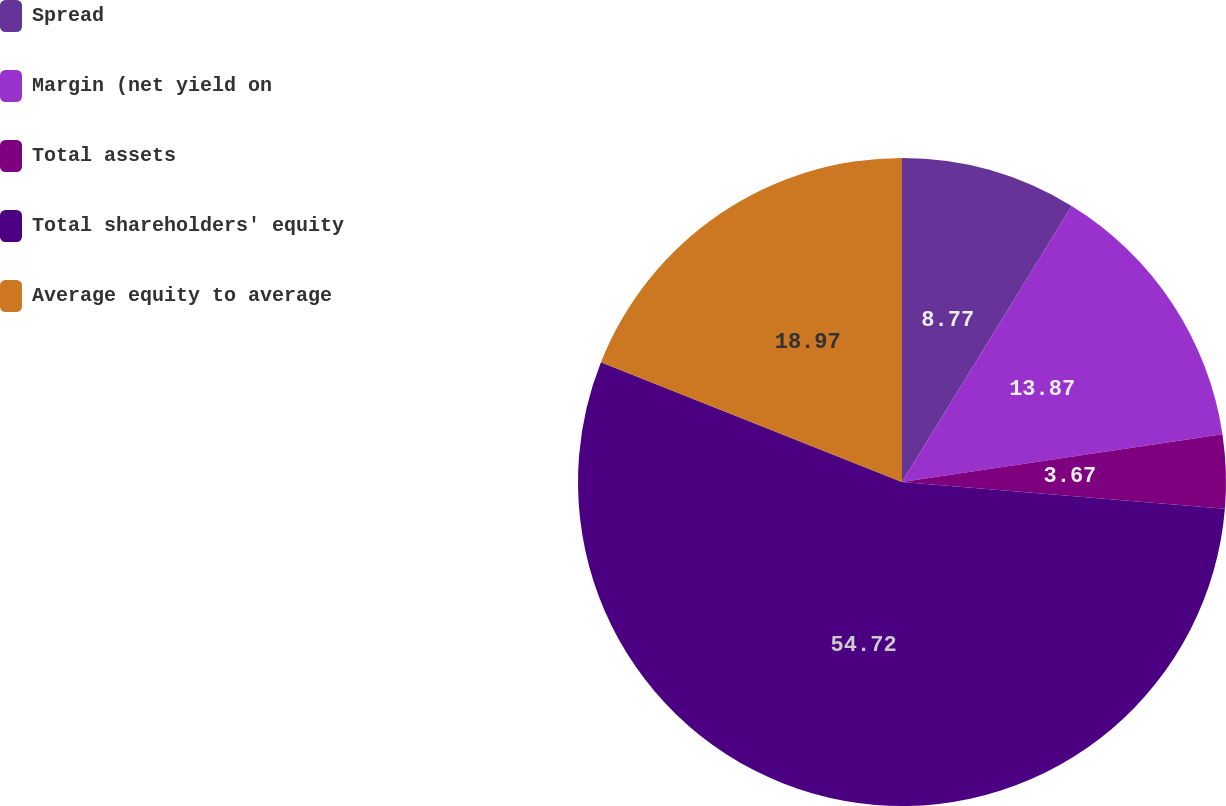<chart> <loc_0><loc_0><loc_500><loc_500><pie_chart><fcel>Spread<fcel>Margin (net yield on<fcel>Total assets<fcel>Total shareholders' equity<fcel>Average equity to average<nl><fcel>8.77%<fcel>13.87%<fcel>3.67%<fcel>54.71%<fcel>18.97%<nl></chart> 